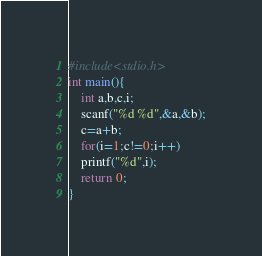Convert code to text. <code><loc_0><loc_0><loc_500><loc_500><_C_>#include<stdio.h>
int main(){
    int a,b,c,i;
    scanf("%d %d",&a,&b);
    c=a+b;
    for(i=1;c!=0;i++)
    printf("%d",i);
    return 0;
}</code> 